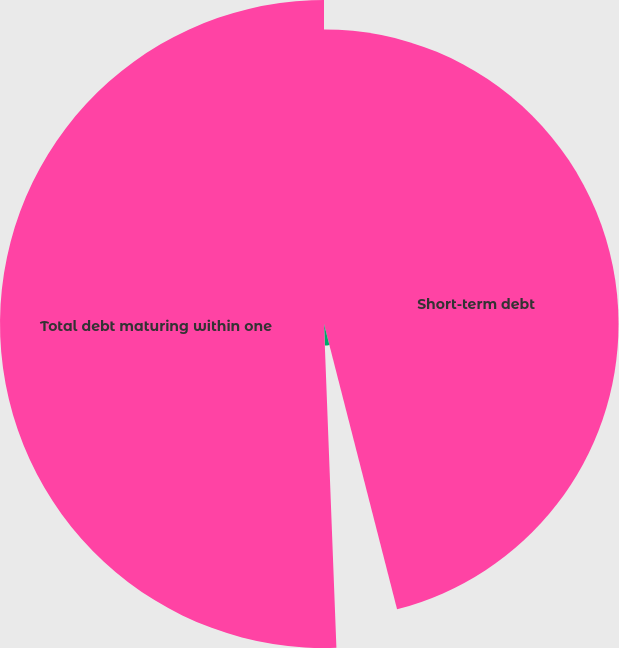Convert chart to OTSL. <chart><loc_0><loc_0><loc_500><loc_500><pie_chart><fcel>Short-term debt<fcel>Current portion of long-term<fcel>Total debt maturing within one<nl><fcel>46.01%<fcel>3.38%<fcel>50.61%<nl></chart> 